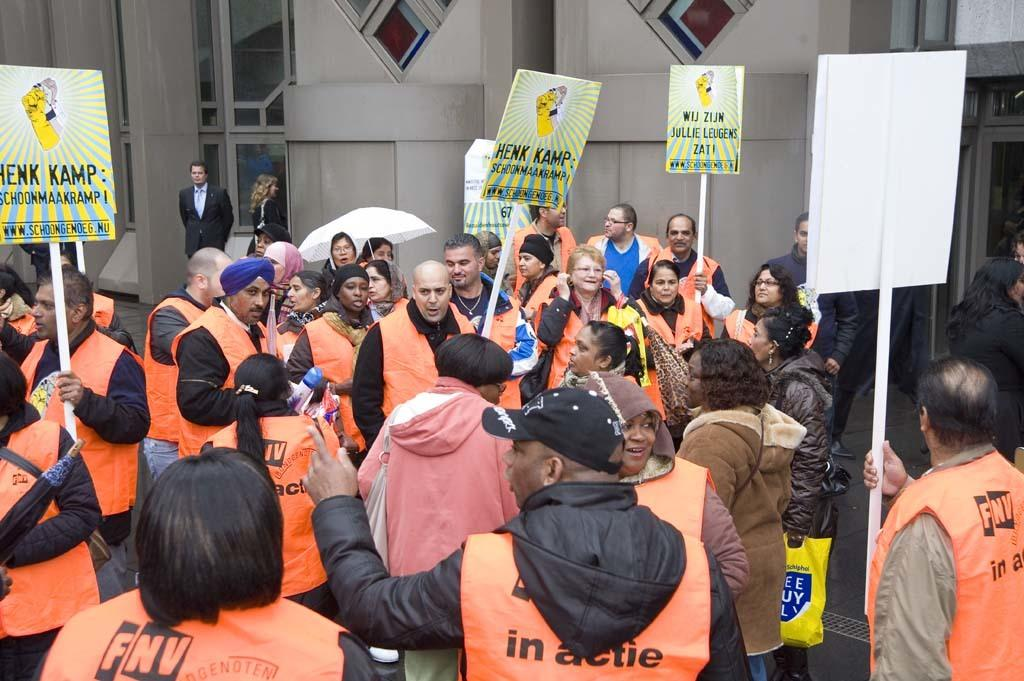<image>
Relay a brief, clear account of the picture shown. Group of people protesting holding signs that say Henk Kamp. 